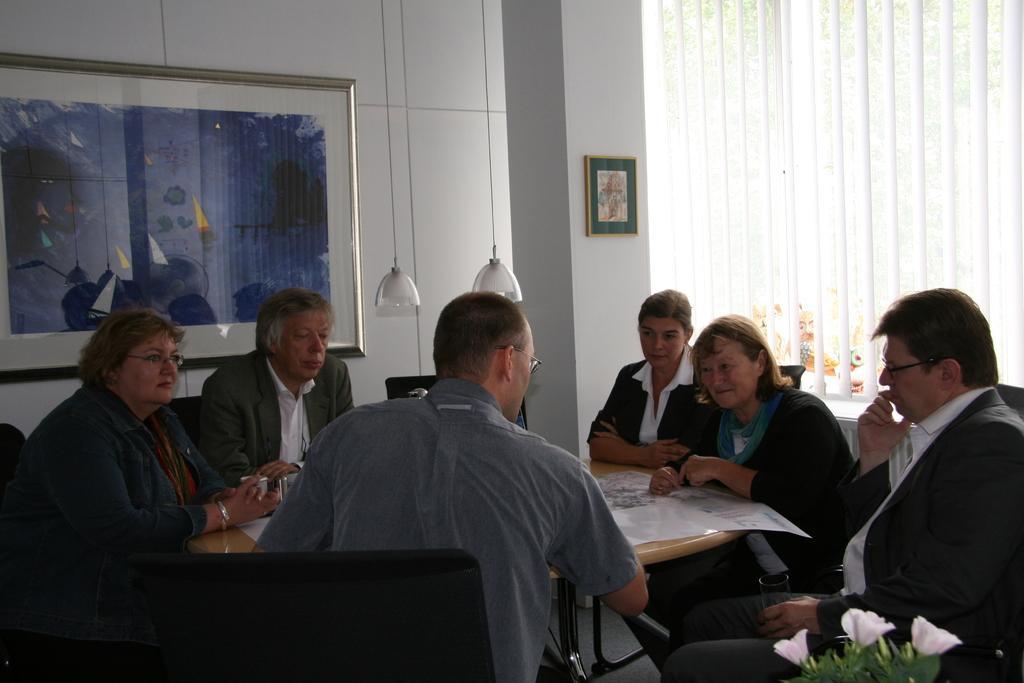In one or two sentences, can you explain what this image depicts? There are few people sitting on the chairs and talking. This is the table with a paper on it. These are the lamps hanging. This is the photo frame attached to the wall. This is the pillar with a frame. This is a small plant with flowers. This is a window with a curtain. 